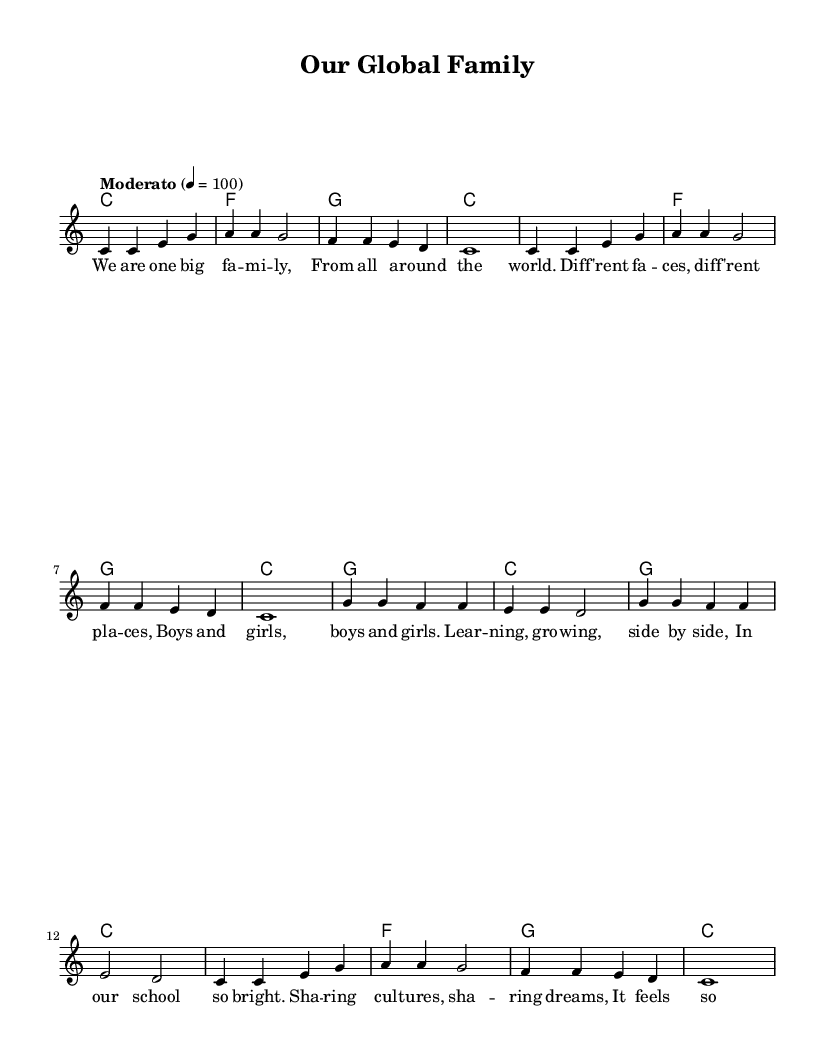What is the key signature of this music? The key signature is C major, which has no sharps or flats.
Answer: C major What is the time signature of this music? The time signature is indicated by the fraction at the beginning, which shows there are four beats in a measure and the quarter note receives one beat.
Answer: 4/4 What is the tempo marking of this piece? The tempo marking is located above the staff, indicating the speed of the piece. It shows "Moderato" with a metronome marking of 100, meaning a moderate pace.
Answer: Moderato, 100 How many measures are in the melody? By counting the individual groups of notes divided by vertical lines (bar lines), we see there are a total of 16 measures in the melody section.
Answer: 16 What are the first two lyrics of the song? The first two phrases of lyrics under the notes can be seen; they correspond to the first two measures as indicated. They start with "We are one big fam."
Answer: We are one big fam Which chord is used in measure 5? By looking at the chord symbols above the staff in measure 5, we see that the chord designated for that measure is the F major chord.
Answer: F What is the overall theme of the song? The lyrics convey a message of unity and diversity, highlighting shared experiences and cultural exchange in a school setting, which is a common theme in multicultural children's songs.
Answer: Unity and diversity 